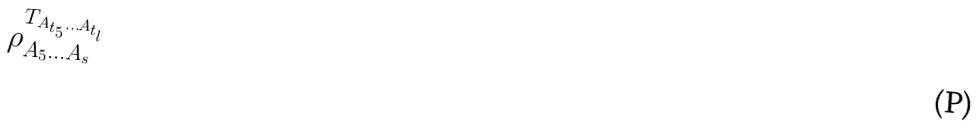Convert formula to latex. <formula><loc_0><loc_0><loc_500><loc_500>\rho _ { A _ { 5 } \dots A _ { s } } ^ { T _ { A _ { t _ { 5 } } \dots A _ { t _ { l } } } }</formula> 